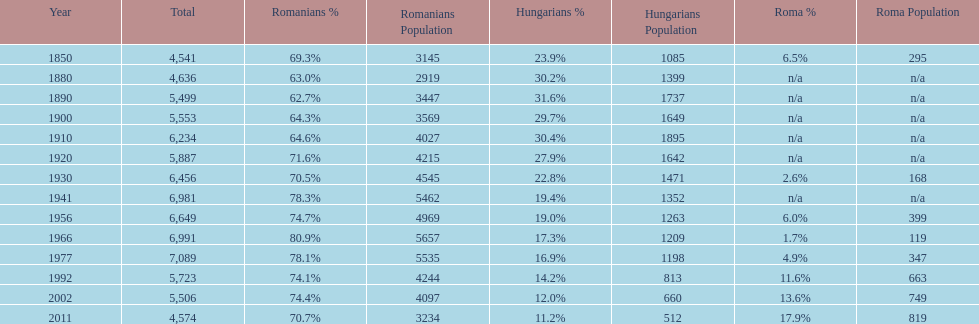Which year had the top percentage in romanian population? 1966. 